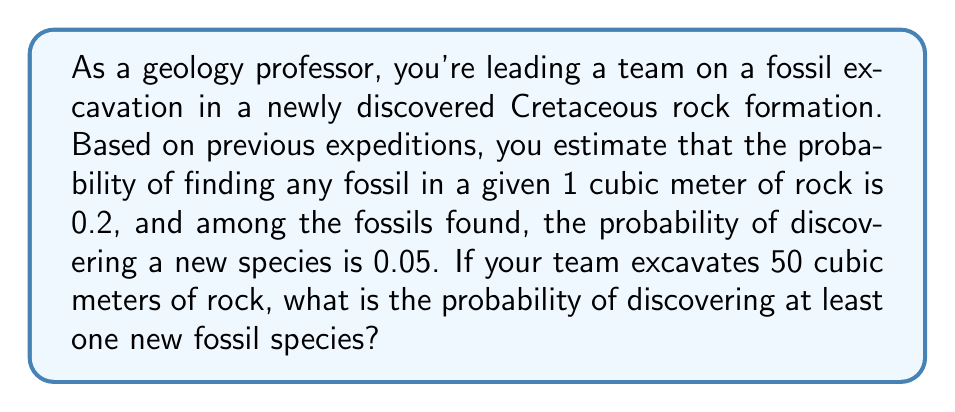Can you answer this question? Let's approach this step-by-step:

1) First, we need to find the probability of discovering a new fossil species in a single cubic meter of rock. This is a compound event:
   $P(\text{new species}) = P(\text{fossil}) \times P(\text{new species | fossil})$
   $P(\text{new species}) = 0.2 \times 0.05 = 0.01$

2) Now, we need to find the probability of not discovering a new species in a single cubic meter:
   $P(\text{no new species}) = 1 - P(\text{new species}) = 1 - 0.01 = 0.99$

3) For 50 cubic meters, we want the probability of not discovering a new species in any of them. Assuming independence, this is:
   $P(\text{no new species in 50 m}^3) = (0.99)^{50}$

4) Therefore, the probability of discovering at least one new species is the complement of this:
   $P(\text{at least one new species}) = 1 - P(\text{no new species in 50 m}^3)$
   $= 1 - (0.99)^{50}$

5) We can calculate this:
   $1 - (0.99)^{50} \approx 1 - 0.6058 = 0.3942$

This can be interpreted in the context of the age of the Earth. Given that the Cretaceous period lasted from about 145 to 66 million years ago, this probability reflects the chance of finding new species from a time when Earth was already billions of years old, showcasing the vast diversity of life that has existed throughout Earth's long history.
Answer: The probability of discovering at least one new fossil species when excavating 50 cubic meters of rock is approximately 0.3942 or 39.42%. 